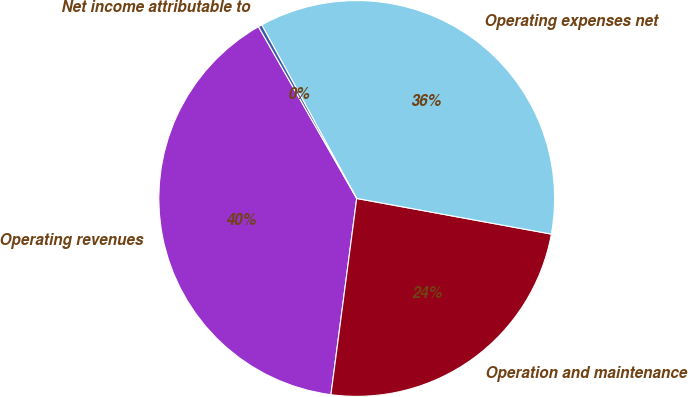Convert chart to OTSL. <chart><loc_0><loc_0><loc_500><loc_500><pie_chart><fcel>Operating revenues<fcel>Operation and maintenance<fcel>Operating expenses net<fcel>Net income attributable to<nl><fcel>39.65%<fcel>24.2%<fcel>35.85%<fcel>0.3%<nl></chart> 